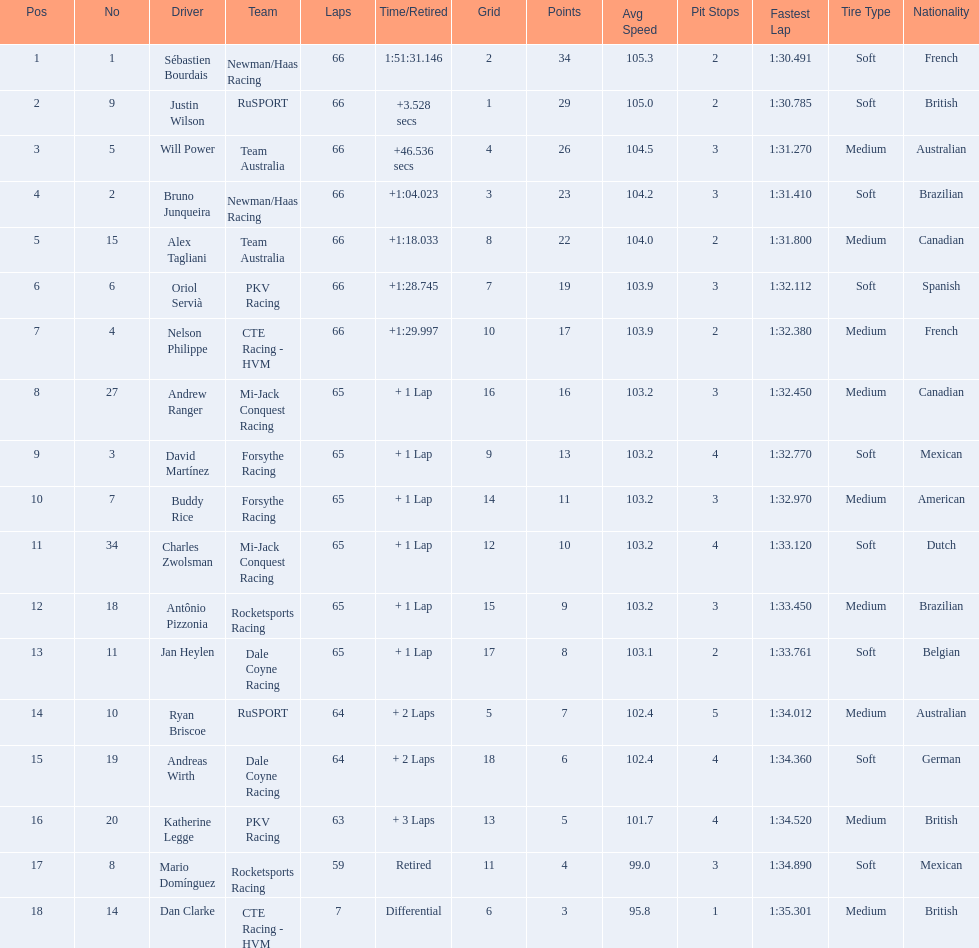What was the highest amount of points scored in the 2006 gran premio? 34. Who scored 34 points? Sébastien Bourdais. 